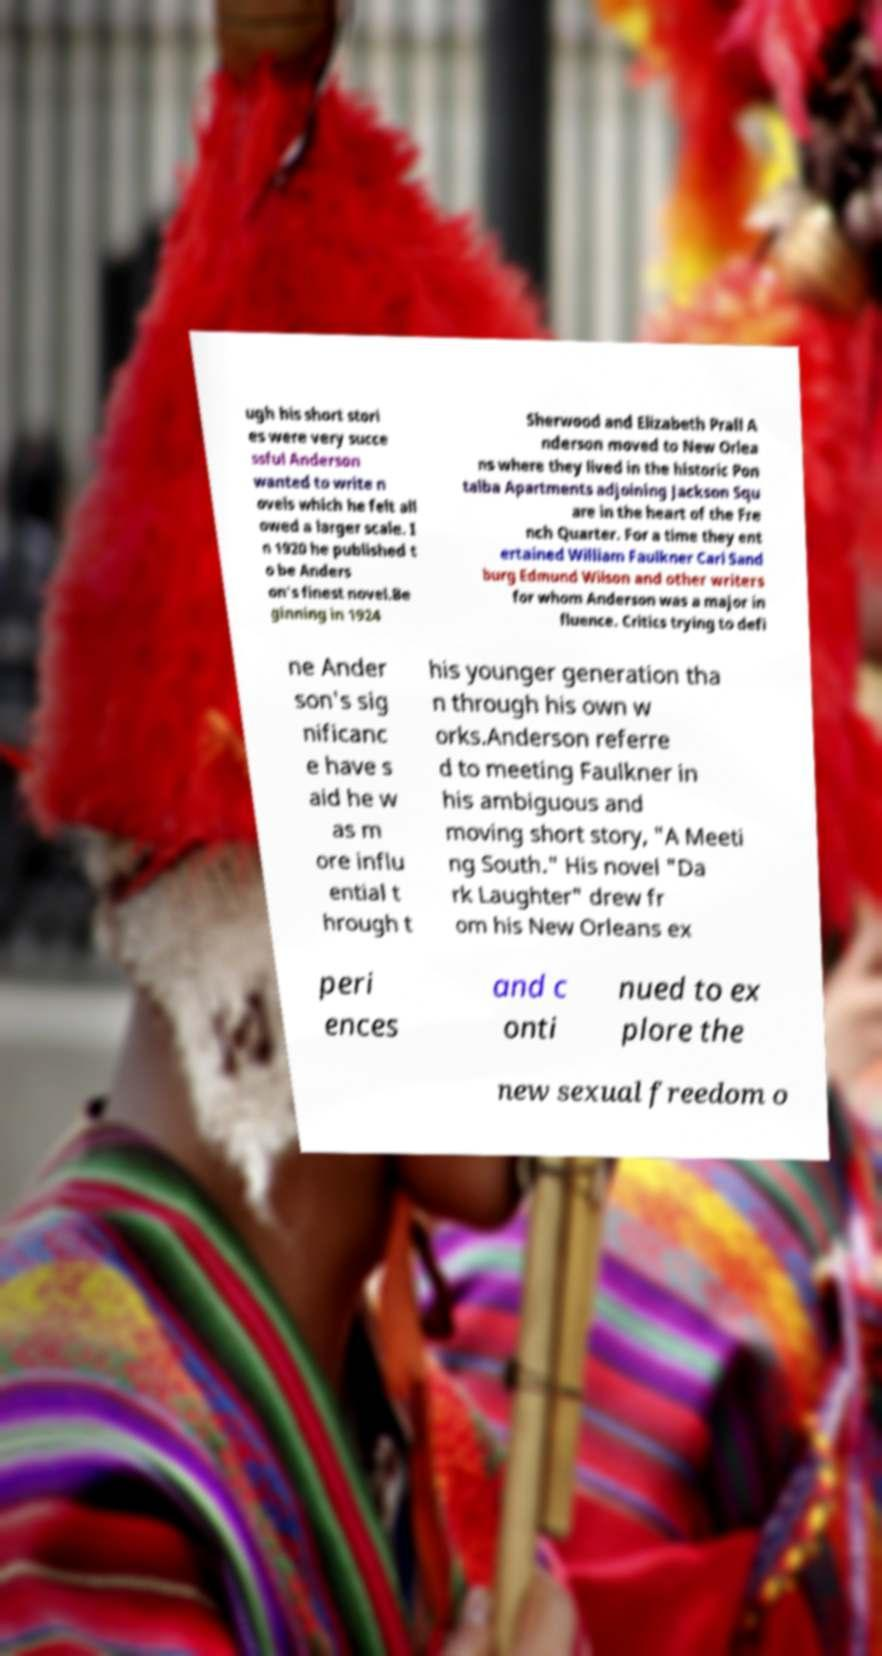Can you accurately transcribe the text from the provided image for me? ugh his short stori es were very succe ssful Anderson wanted to write n ovels which he felt all owed a larger scale. I n 1920 he published t o be Anders on's finest novel.Be ginning in 1924 Sherwood and Elizabeth Prall A nderson moved to New Orlea ns where they lived in the historic Pon talba Apartments adjoining Jackson Squ are in the heart of the Fre nch Quarter. For a time they ent ertained William Faulkner Carl Sand burg Edmund Wilson and other writers for whom Anderson was a major in fluence. Critics trying to defi ne Ander son's sig nificanc e have s aid he w as m ore influ ential t hrough t his younger generation tha n through his own w orks.Anderson referre d to meeting Faulkner in his ambiguous and moving short story, "A Meeti ng South." His novel "Da rk Laughter" drew fr om his New Orleans ex peri ences and c onti nued to ex plore the new sexual freedom o 